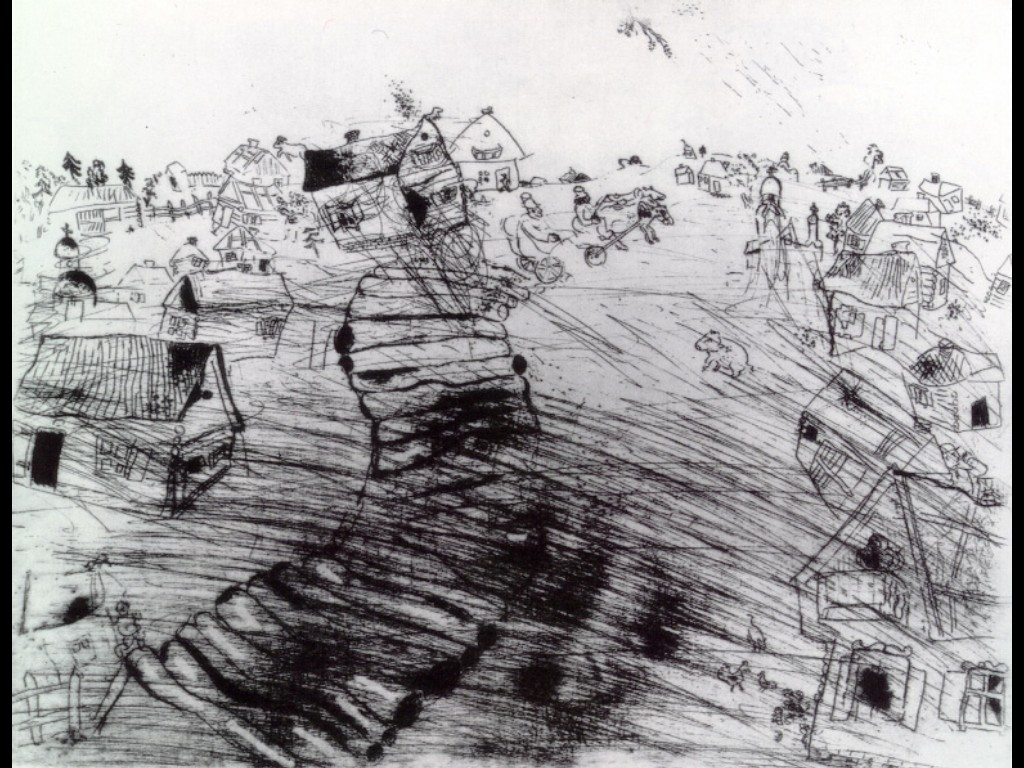Let's think creatively: what story do you imagine behind the scene depicted in this sketch? In the whimsical world of this village, the scene depicts a festival day, where the winding road is momentarily transformed into a bustling marketplace. Villagers from all walks of life converge here, sharing laughter and stories, trading goods, and celebrating their community's resilience. Amid the animated crowd, a child discovers an old, mysterious map hinting at long-forgotten village treasures, setting off an adventurous quest that brings the villagers closer together, reinforcing their unity and shared heritage. What can you tell about the daily life of this village's inhabitants based on the image? The daily life of the inhabitants of this village seems to be vibrant and deeply intertwined with community activities. The image shows people engaging in various everyday tasks and leisure activities—walking along the main road, riding bicycles, and playing with children. The presence of multiple figures engaged in different actions suggests a strong sense of community, where everyone knows each other, and social interaction forms an integral part of their daily routine. This rural setting likely thrives on agriculture, local trades, and simple living, with a strong reliance on mutual support and collaboration. Imagine a dramatic scenario involving the village depicted in this sketch. As a storm rages on the horizon, the villagers hastily come together to secure their homes and gather in the central meeting hall. The ominous clouds cast eerie shadows across the landscape, and the sketch suddenly takes on a more urgent, dramatic tone. Certain houses, already leaning precariously, seem to resist the growing winds with immense will. This unanticipated natural challenge tests the village's resilience, unwavering spirit, and camaraderie. In the aftermath, despite destruction, a collective spirit emerges stronger, with rebuilding efforts transforming the village into an even more closely-knit community. Can we talk more casually about the image? What catches your eye first? Sure! The first thing that catches my eye is the winding road that sweeps through the heart of the village. It’s such a dynamic element that it immediately draws attention and gives the scene a sense of movement. The road seems almost like it's inviting you to take a stroll through the village. The playful, tilting buildings and the lively depictions of people going about their day also stand out, making it feel like a snapshot of an animated moment frozen in time. 